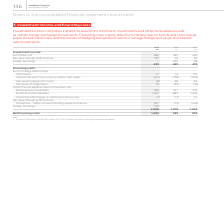From Vodafone Group Plc's financial document, Which financial years' information is shown in the table? The document contains multiple relevant values: 2017, 2018, 2019. From the document: "2019 2018 2017 €m €m €m Investment income: Amortised cost 286 339 426 Fair value through profit and loss 147 24 20 2019 2018 2017 €m €m €m Investment ..." Also, What does investment income comprise of? interest received from short-term investments and other receivables as well as certain foreign exchange movements. The document states: "Investment income comprises interest received from short-term investments and other receivables as well as certain foreign exchange movements. Financi..." Also, How much is the 2019 amortised cost under investment income? According to the financial document, 286 (in millions). The relevant text states: "8 2017 €m €m €m Investment income: Amortised cost 286 339 426 Fair value through profit and loss 147 24 20 Foreign exchange – 322 28 433 685 474 Financin..." Also, can you calculate: How much is the 2019 bonds and other liabilities, excluding the interest on foreign exchange derivatives? Based on the calculation: 1,567-305 , the result is 1262 (in millions). This is based on the information: "rdrafts 336 317 419 Bonds and other liabilities 1 1,567 885 1,243 Interest (credit)/charge on settlement of tax issues (1) (11) 47 Fair value through profi Note: 1 Includes €305 million (2018: €187 mi..." The key data points involved are: 1,567, 305. Also, can you calculate: How much is the 2018 bonds and other liabilities, excluding the interest on foreign exchange derivatives? Based on the calculation: 885-187, the result is 698 (in millions). This is based on the information: "s 336 317 419 Bonds and other liabilities 1 1,567 885 1,243 Interest (credit)/charge on settlement of tax issues (1) (11) 47 Fair value through profit an Note: 1 Includes €305 million (2018: €187 mill..." The key data points involved are: 187, 885. Also, can you calculate: How much is the 2017 bonds and other liabilities, excluding the interest on foreign exchange derivatives? Based on the calculation: 1,243-272, the result is 971 (in millions). This is based on the information: "6 317 419 Bonds and other liabilities 1 1,567 885 1,243 Interest (credit)/charge on settlement of tax issues (1) (11) 47 Fair value through profit and loss Includes €305 million (2018: €187 million; 2..." The key data points involved are: 1,243, 272. 